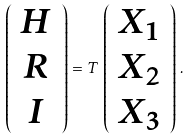<formula> <loc_0><loc_0><loc_500><loc_500>\left ( \begin{array} { c } { H } \\ { R } \\ { I } \end{array} \right ) = T \, \left ( \begin{array} { c } { { X _ { 1 } } } \\ { { X _ { 2 } } } \\ { { X _ { 3 } } } \end{array} \right ) \, .</formula> 